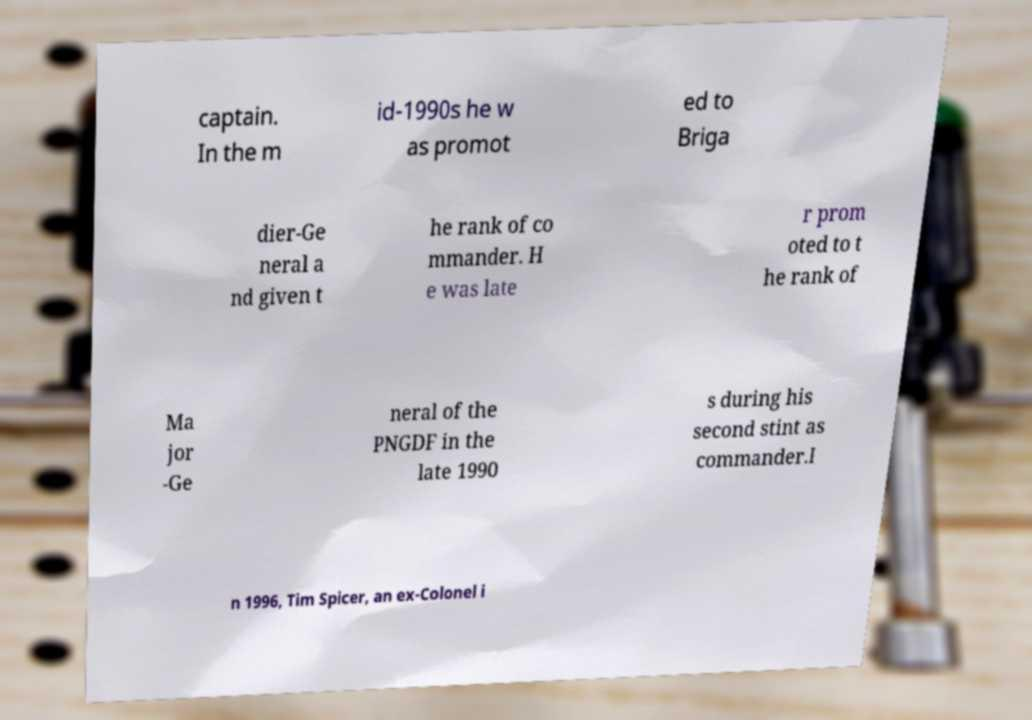For documentation purposes, I need the text within this image transcribed. Could you provide that? captain. In the m id-1990s he w as promot ed to Briga dier-Ge neral a nd given t he rank of co mmander. H e was late r prom oted to t he rank of Ma jor -Ge neral of the PNGDF in the late 1990 s during his second stint as commander.I n 1996, Tim Spicer, an ex-Colonel i 